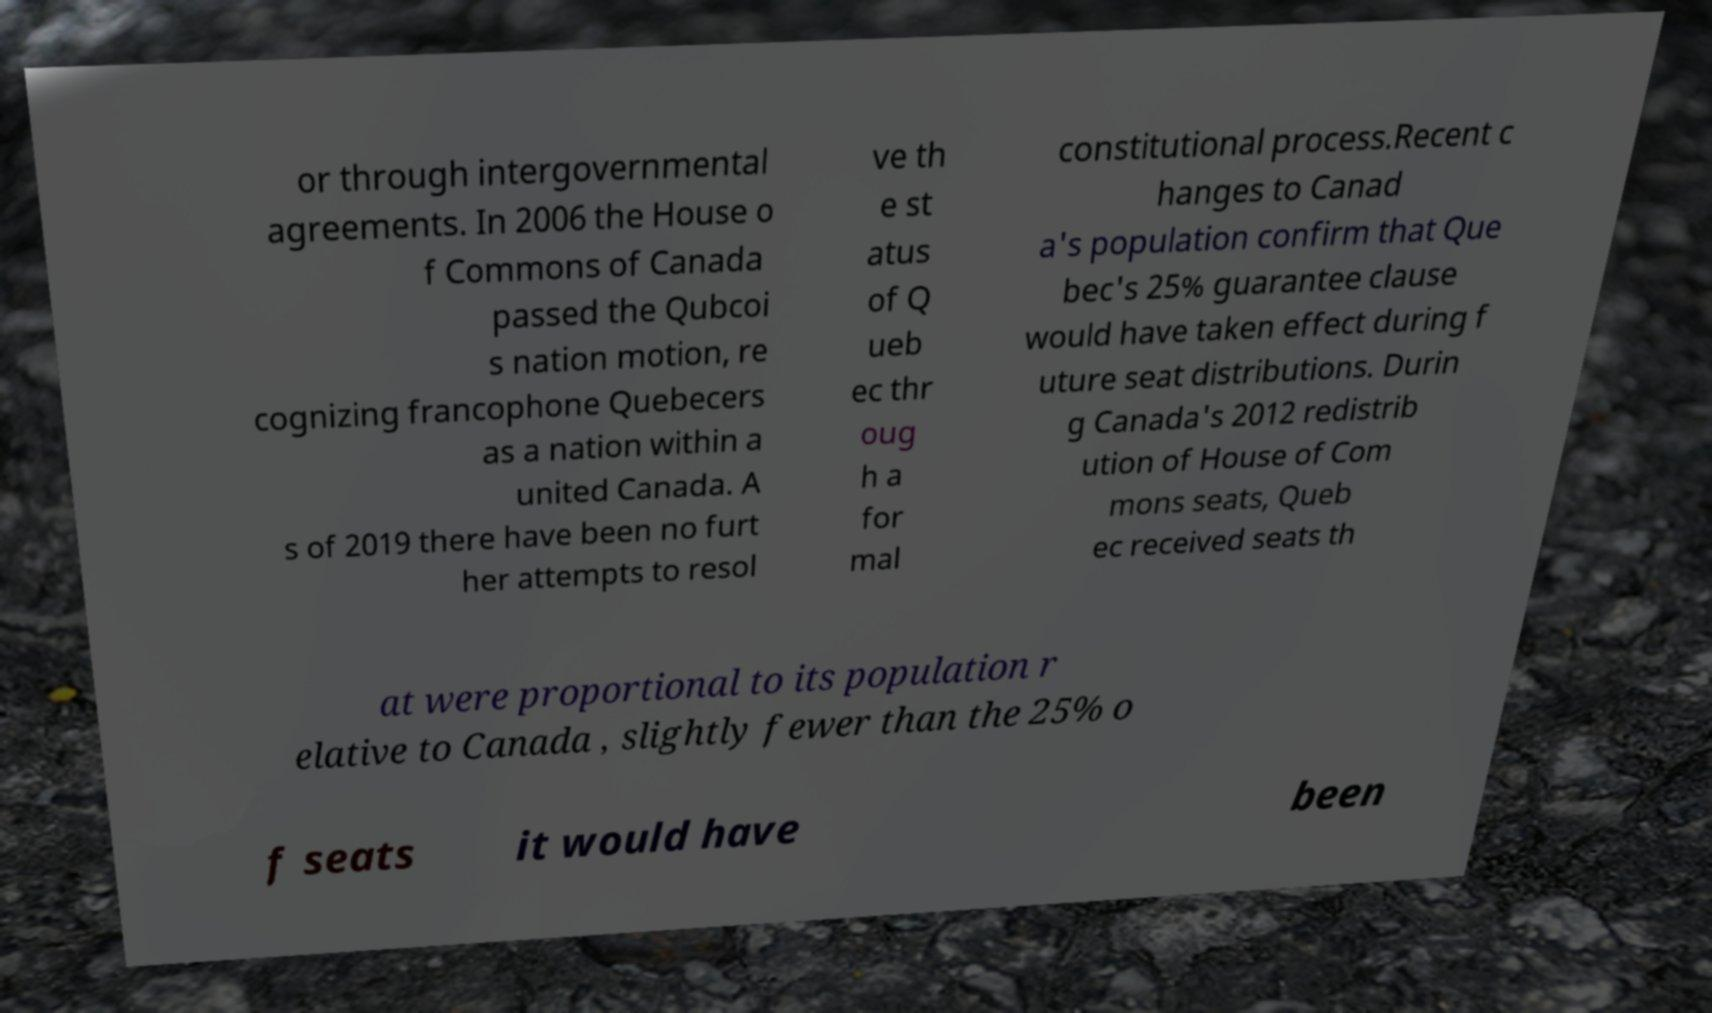Could you extract and type out the text from this image? or through intergovernmental agreements. In 2006 the House o f Commons of Canada passed the Qubcoi s nation motion, re cognizing francophone Quebecers as a nation within a united Canada. A s of 2019 there have been no furt her attempts to resol ve th e st atus of Q ueb ec thr oug h a for mal constitutional process.Recent c hanges to Canad a's population confirm that Que bec's 25% guarantee clause would have taken effect during f uture seat distributions. Durin g Canada's 2012 redistrib ution of House of Com mons seats, Queb ec received seats th at were proportional to its population r elative to Canada , slightly fewer than the 25% o f seats it would have been 